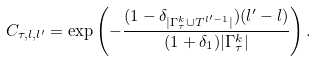Convert formula to latex. <formula><loc_0><loc_0><loc_500><loc_500>C _ { \tau , l , l ^ { \prime } } = \exp \left ( - \frac { ( 1 - \delta _ { | { \Gamma } ^ { k } _ { \tau } \cup T ^ { l ^ { \prime } - 1 } | } ) ( l ^ { \prime } - l ) } { ( 1 + \delta _ { 1 } ) | { \Gamma } ^ { k } _ { \tau } | } \right ) .</formula> 